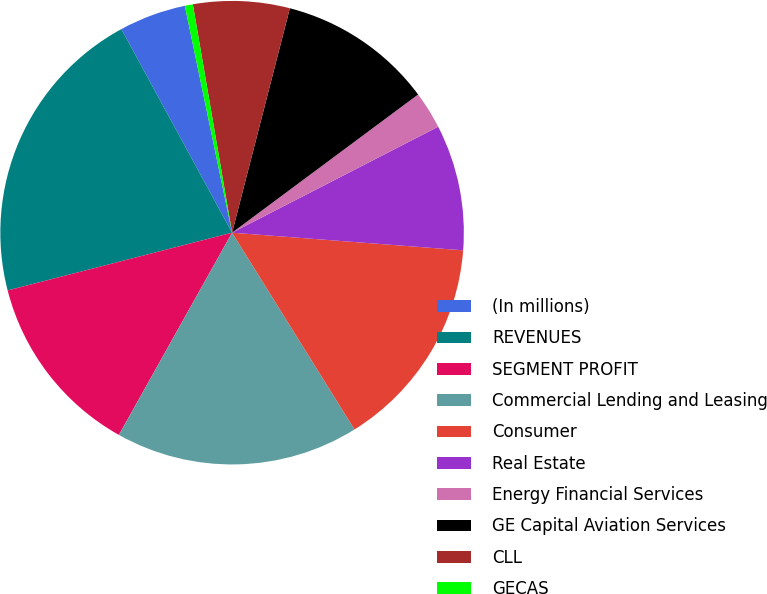<chart> <loc_0><loc_0><loc_500><loc_500><pie_chart><fcel>(In millions)<fcel>REVENUES<fcel>SEGMENT PROFIT<fcel>Commercial Lending and Leasing<fcel>Consumer<fcel>Real Estate<fcel>Energy Financial Services<fcel>GE Capital Aviation Services<fcel>CLL<fcel>GECAS<nl><fcel>4.66%<fcel>21.08%<fcel>12.87%<fcel>16.98%<fcel>14.93%<fcel>8.77%<fcel>2.61%<fcel>10.82%<fcel>6.72%<fcel>0.56%<nl></chart> 